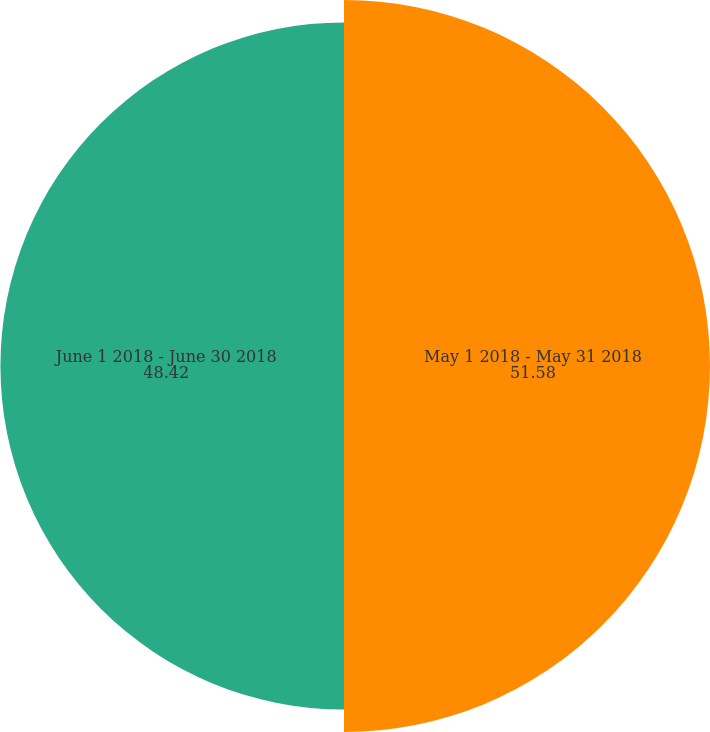Convert chart. <chart><loc_0><loc_0><loc_500><loc_500><pie_chart><fcel>May 1 2018 - May 31 2018<fcel>June 1 2018 - June 30 2018<nl><fcel>51.58%<fcel>48.42%<nl></chart> 